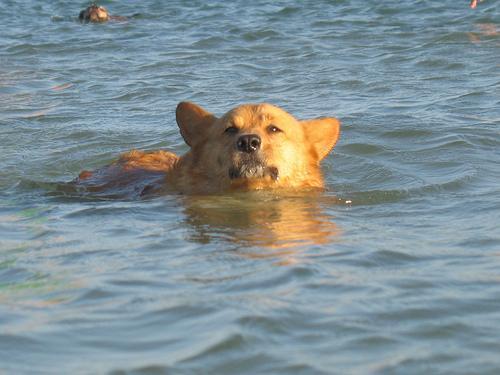How many dogs are in the picture?
Give a very brief answer. 1. 